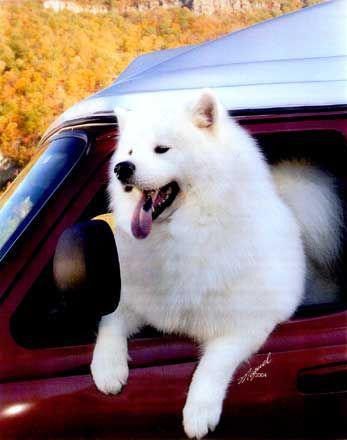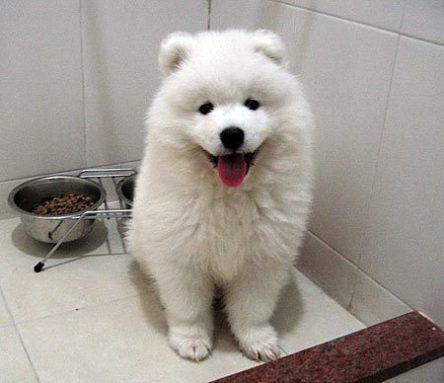The first image is the image on the left, the second image is the image on the right. Considering the images on both sides, is "There are at least two dogs in the image on the right." valid? Answer yes or no. No. The first image is the image on the left, the second image is the image on the right. Evaluate the accuracy of this statement regarding the images: "A white dog is outside in the snow.". Is it true? Answer yes or no. No. 